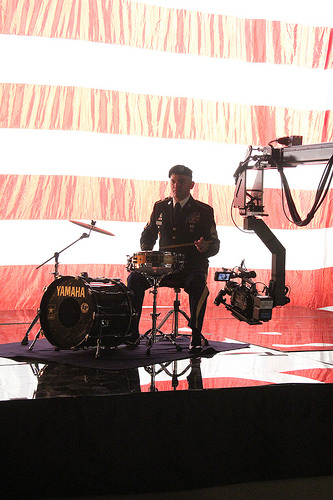<image>
Is there a stool behind the camera? No. The stool is not behind the camera. From this viewpoint, the stool appears to be positioned elsewhere in the scene. 